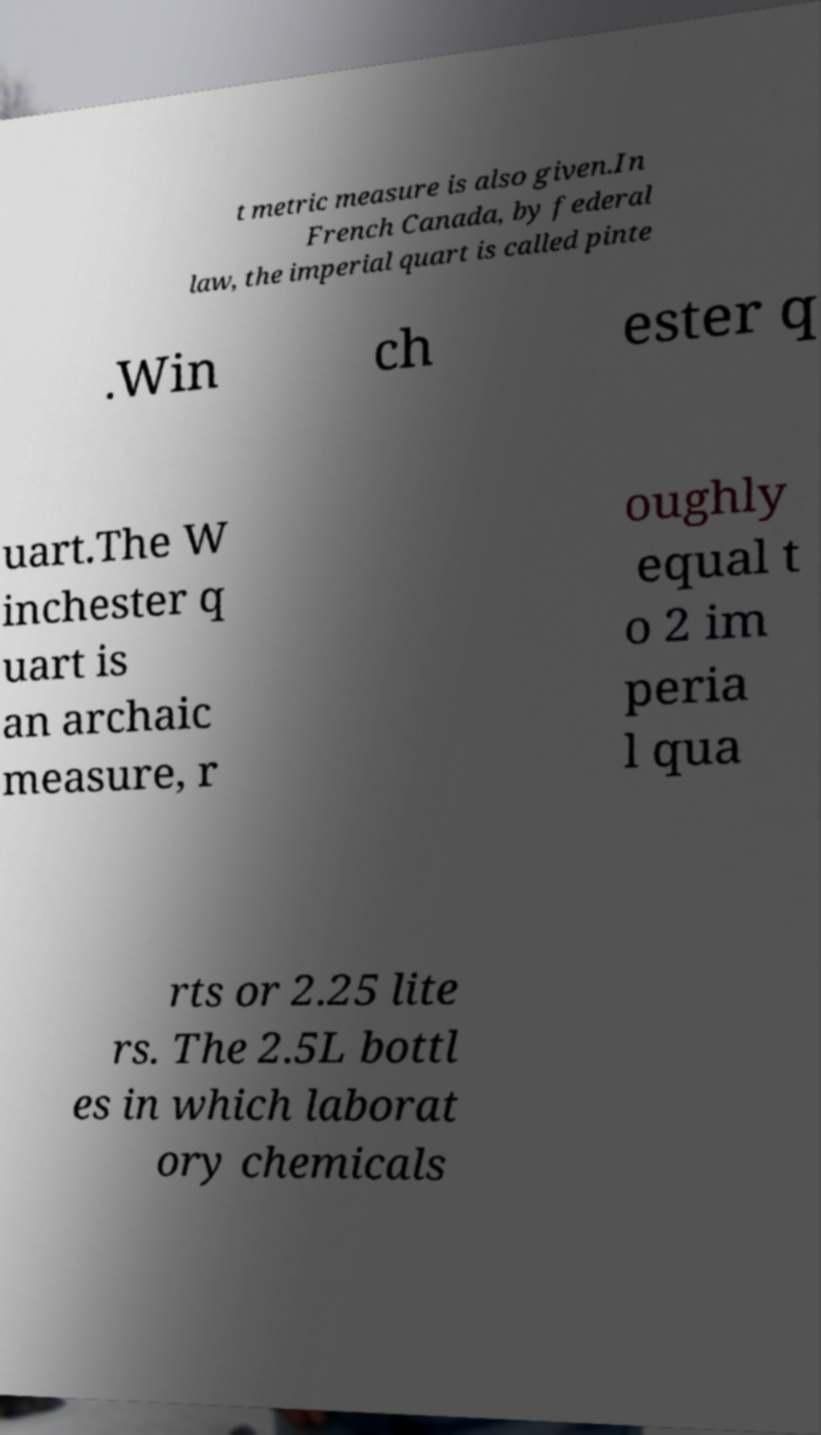Could you assist in decoding the text presented in this image and type it out clearly? t metric measure is also given.In French Canada, by federal law, the imperial quart is called pinte .Win ch ester q uart.The W inchester q uart is an archaic measure, r oughly equal t o 2 im peria l qua rts or 2.25 lite rs. The 2.5L bottl es in which laborat ory chemicals 